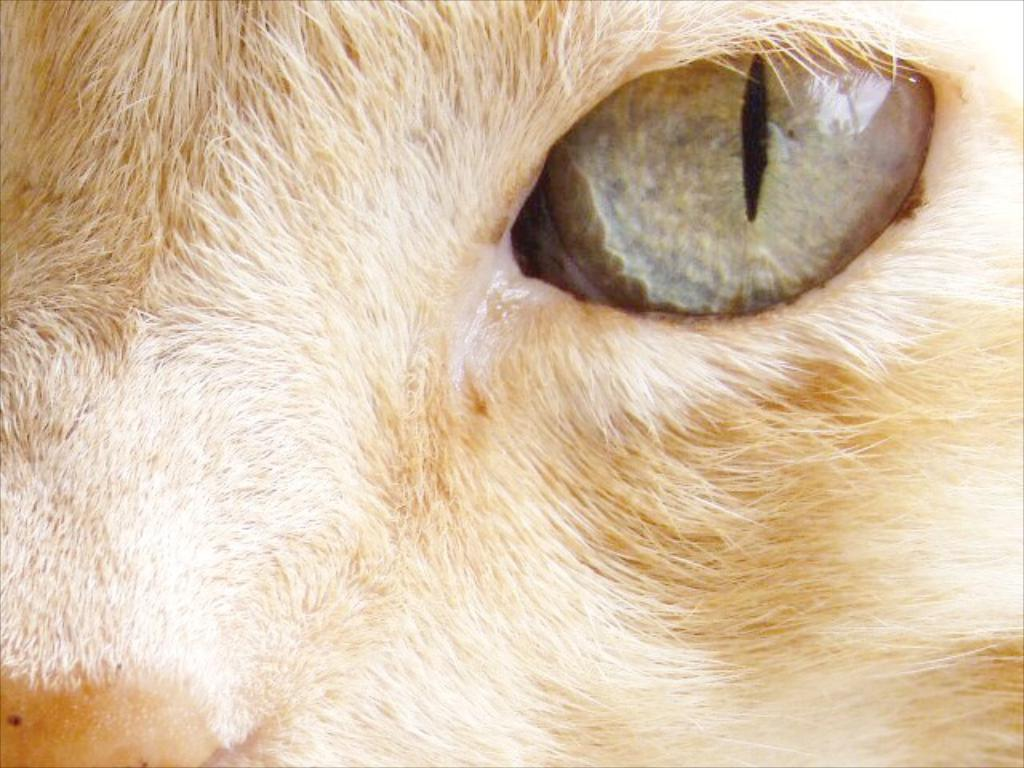What type of animal is present in the image? There is an animal in the image, but its specific type cannot be determined from the provided facts. Can you describe the color of the animal in the image? The animal is in brownish color. Where is the eye visible in the image? The eye is visible to the right in the image. What type of rail can be seen in the image? There is no rail present in the image. What is the condition of the rain in the image? There is no rain present in the image. 